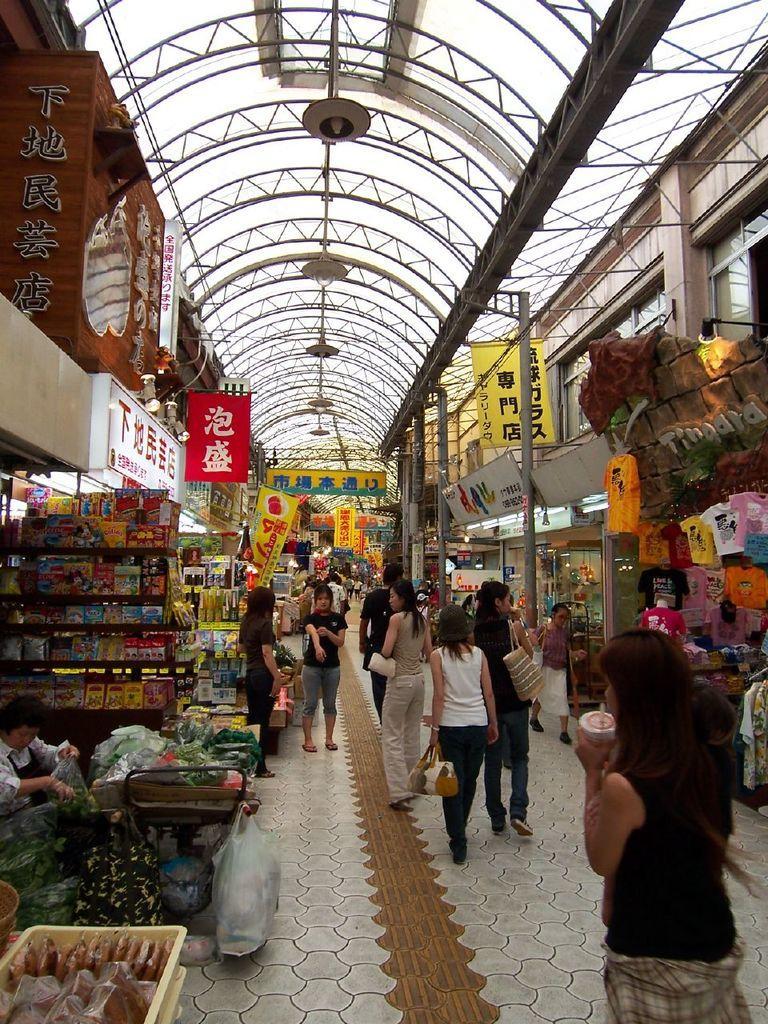Please provide a concise description of this image. This image is clicked inside a mall. There are a few people walking on the floor. In the bottom left there are vegetables in the baskets. Beside it there are books in the racks. To the right there are t-shirts hanging on the rods. On the either sides of the image there boards and banners to the walls. At the top there is a ceiling. There are lights hanging to the ceiling. 